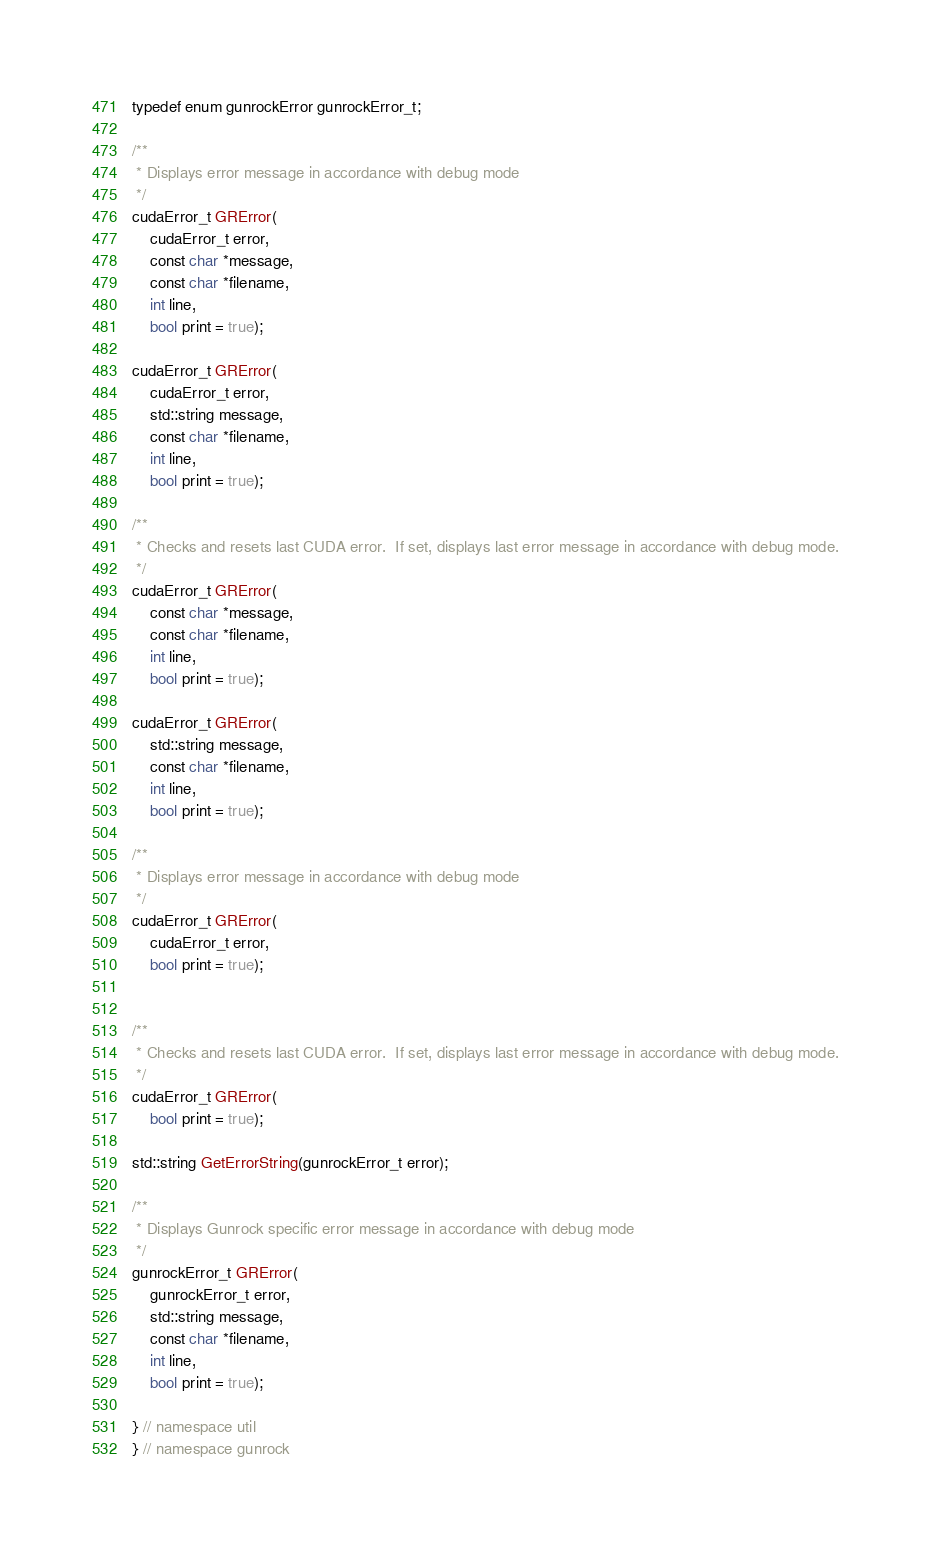Convert code to text. <code><loc_0><loc_0><loc_500><loc_500><_Cuda_>typedef enum gunrockError gunrockError_t;

/**
 * Displays error message in accordance with debug mode
 */
cudaError_t GRError(
    cudaError_t error,
    const char *message,
    const char *filename,
    int line,
    bool print = true);

cudaError_t GRError(
    cudaError_t error,
    std::string message,
    const char *filename,
    int line,
    bool print = true);

/**
 * Checks and resets last CUDA error.  If set, displays last error message in accordance with debug mode.
 */
cudaError_t GRError(
    const char *message,
    const char *filename,
    int line,
    bool print = true);

cudaError_t GRError(
    std::string message,
    const char *filename,
    int line,
    bool print = true);

/**
 * Displays error message in accordance with debug mode
 */
cudaError_t GRError(
    cudaError_t error,
    bool print = true);


/**
 * Checks and resets last CUDA error.  If set, displays last error message in accordance with debug mode.
 */
cudaError_t GRError(
    bool print = true);

std::string GetErrorString(gunrockError_t error);

/**
 * Displays Gunrock specific error message in accordance with debug mode
 */
gunrockError_t GRError(
    gunrockError_t error,
    std::string message,
    const char *filename,
    int line,
    bool print = true);

} // namespace util
} // namespace gunrock

</code> 